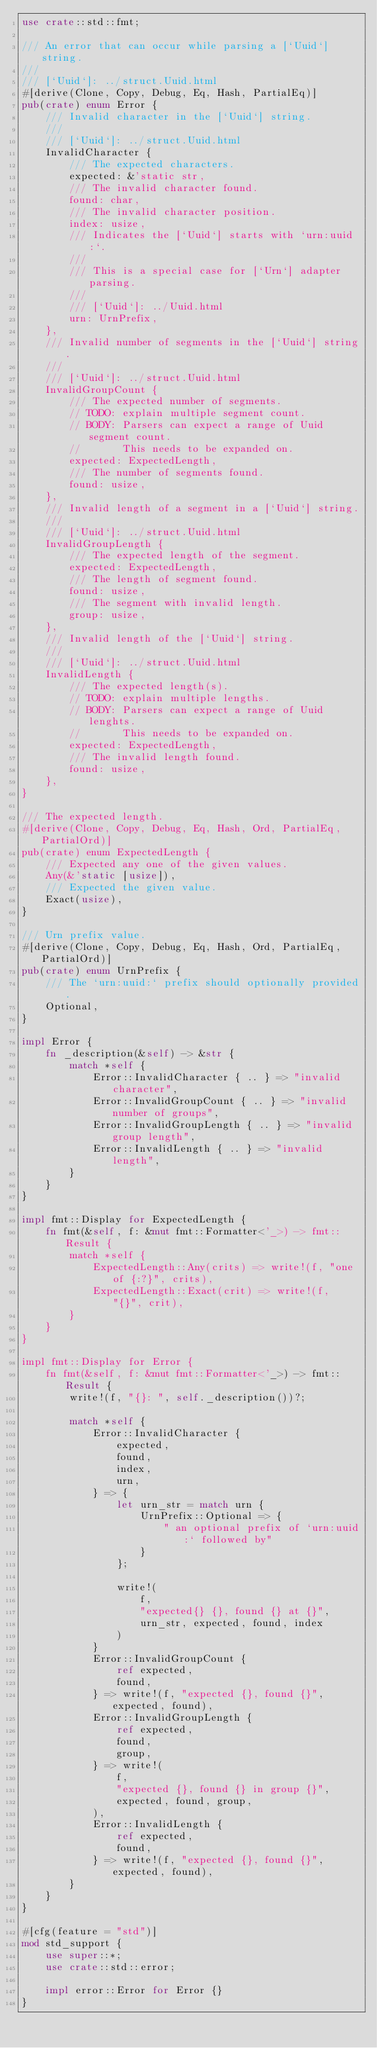Convert code to text. <code><loc_0><loc_0><loc_500><loc_500><_Rust_>use crate::std::fmt;

/// An error that can occur while parsing a [`Uuid`] string.
///
/// [`Uuid`]: ../struct.Uuid.html
#[derive(Clone, Copy, Debug, Eq, Hash, PartialEq)]
pub(crate) enum Error {
    /// Invalid character in the [`Uuid`] string.
    ///
    /// [`Uuid`]: ../struct.Uuid.html
    InvalidCharacter {
        /// The expected characters.
        expected: &'static str,
        /// The invalid character found.
        found: char,
        /// The invalid character position.
        index: usize,
        /// Indicates the [`Uuid`] starts with `urn:uuid:`.
        ///
        /// This is a special case for [`Urn`] adapter parsing.
        ///
        /// [`Uuid`]: ../Uuid.html
        urn: UrnPrefix,
    },
    /// Invalid number of segments in the [`Uuid`] string.
    ///
    /// [`Uuid`]: ../struct.Uuid.html
    InvalidGroupCount {
        /// The expected number of segments.
        // TODO: explain multiple segment count.
        // BODY: Parsers can expect a range of Uuid segment count.
        //       This needs to be expanded on.
        expected: ExpectedLength,
        /// The number of segments found.
        found: usize,
    },
    /// Invalid length of a segment in a [`Uuid`] string.
    ///
    /// [`Uuid`]: ../struct.Uuid.html
    InvalidGroupLength {
        /// The expected length of the segment.
        expected: ExpectedLength,
        /// The length of segment found.
        found: usize,
        /// The segment with invalid length.
        group: usize,
    },
    /// Invalid length of the [`Uuid`] string.
    ///
    /// [`Uuid`]: ../struct.Uuid.html
    InvalidLength {
        /// The expected length(s).
        // TODO: explain multiple lengths.
        // BODY: Parsers can expect a range of Uuid lenghts.
        //       This needs to be expanded on.
        expected: ExpectedLength,
        /// The invalid length found.
        found: usize,
    },
}

/// The expected length.
#[derive(Clone, Copy, Debug, Eq, Hash, Ord, PartialEq, PartialOrd)]
pub(crate) enum ExpectedLength {
    /// Expected any one of the given values.
    Any(&'static [usize]),
    /// Expected the given value.
    Exact(usize),
}

/// Urn prefix value.
#[derive(Clone, Copy, Debug, Eq, Hash, Ord, PartialEq, PartialOrd)]
pub(crate) enum UrnPrefix {
    /// The `urn:uuid:` prefix should optionally provided.
    Optional,
}

impl Error {
    fn _description(&self) -> &str {
        match *self {
            Error::InvalidCharacter { .. } => "invalid character",
            Error::InvalidGroupCount { .. } => "invalid number of groups",
            Error::InvalidGroupLength { .. } => "invalid group length",
            Error::InvalidLength { .. } => "invalid length",
        }
    }
}

impl fmt::Display for ExpectedLength {
    fn fmt(&self, f: &mut fmt::Formatter<'_>) -> fmt::Result {
        match *self {
            ExpectedLength::Any(crits) => write!(f, "one of {:?}", crits),
            ExpectedLength::Exact(crit) => write!(f, "{}", crit),
        }
    }
}

impl fmt::Display for Error {
    fn fmt(&self, f: &mut fmt::Formatter<'_>) -> fmt::Result {
        write!(f, "{}: ", self._description())?;

        match *self {
            Error::InvalidCharacter {
                expected,
                found,
                index,
                urn,
            } => {
                let urn_str = match urn {
                    UrnPrefix::Optional => {
                        " an optional prefix of `urn:uuid:` followed by"
                    }
                };

                write!(
                    f,
                    "expected{} {}, found {} at {}",
                    urn_str, expected, found, index
                )
            }
            Error::InvalidGroupCount {
                ref expected,
                found,
            } => write!(f, "expected {}, found {}", expected, found),
            Error::InvalidGroupLength {
                ref expected,
                found,
                group,
            } => write!(
                f,
                "expected {}, found {} in group {}",
                expected, found, group,
            ),
            Error::InvalidLength {
                ref expected,
                found,
            } => write!(f, "expected {}, found {}", expected, found),
        }
    }
}

#[cfg(feature = "std")]
mod std_support {
    use super::*;
    use crate::std::error;

    impl error::Error for Error {}
}
</code> 